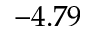Convert formula to latex. <formula><loc_0><loc_0><loc_500><loc_500>- 4 . 7 9</formula> 